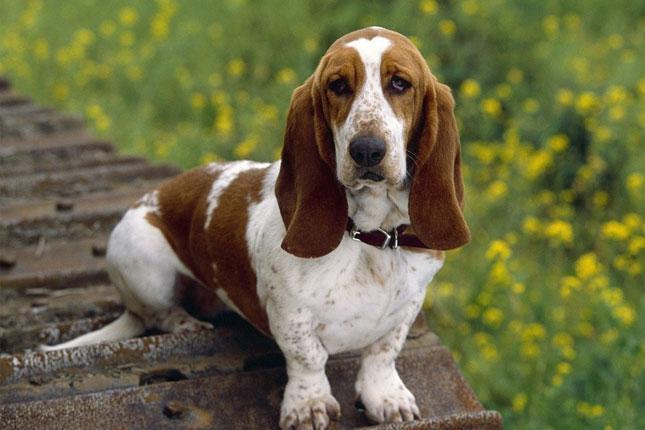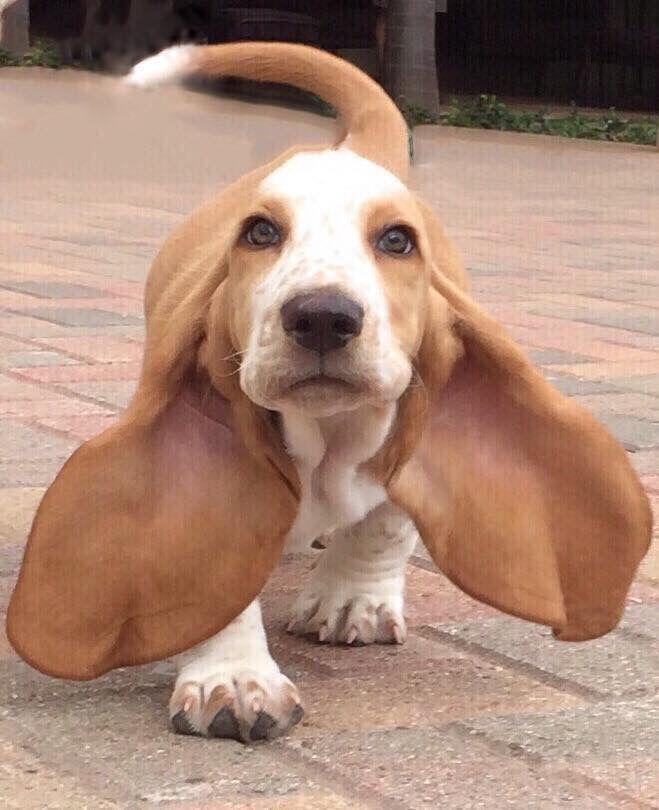The first image is the image on the left, the second image is the image on the right. Given the left and right images, does the statement "Exactly one dog tongue can be seen in one of the images." hold true? Answer yes or no. No. 